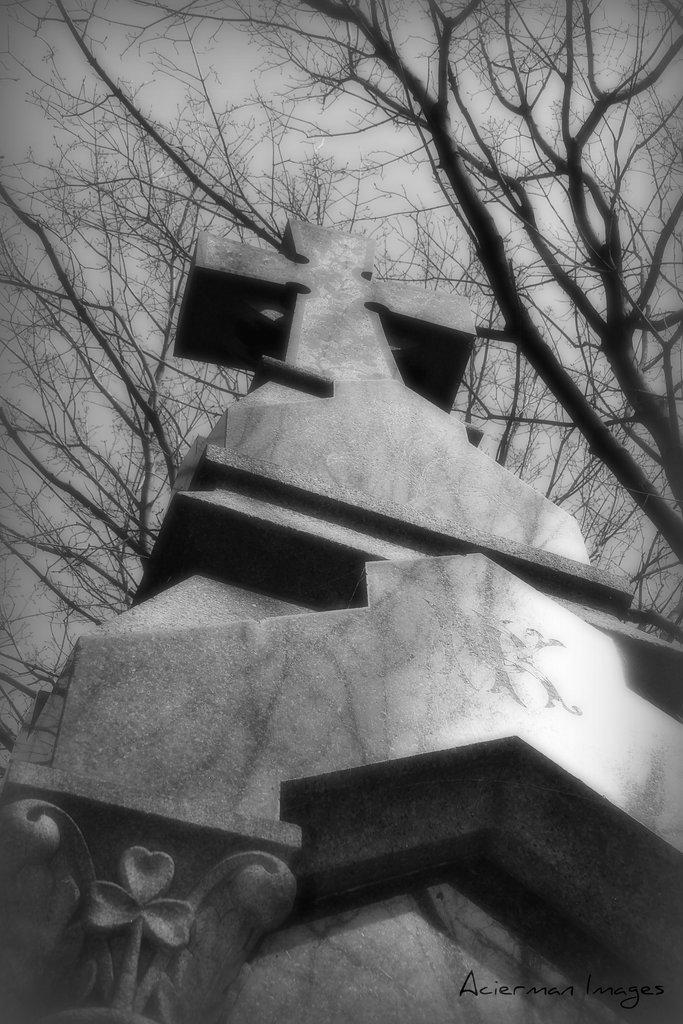What is the main subject in the image? There is a statue in the image. What type of natural elements can be seen in the image? There are trees in the image. What is visible in the background of the image? The sky is visible in the image. What type of tub can be seen in the image? There is no tub present in the image. 